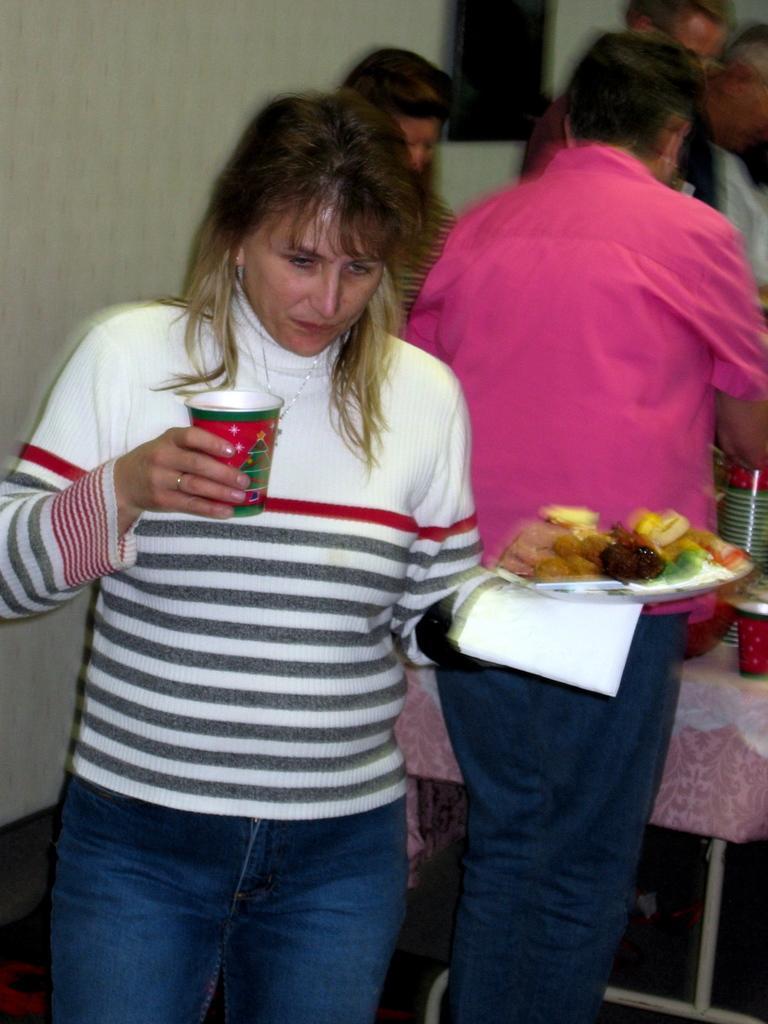How would you summarize this image in a sentence or two? In this image we can see a woman is standing and holding a plate with food items in it in the hand and a cup in the another hand. In the background there are few persons, objects on the table and a frame on the wall. 